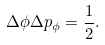Convert formula to latex. <formula><loc_0><loc_0><loc_500><loc_500>\Delta \phi \Delta p _ { \phi } = \frac { 1 } { 2 } .</formula> 